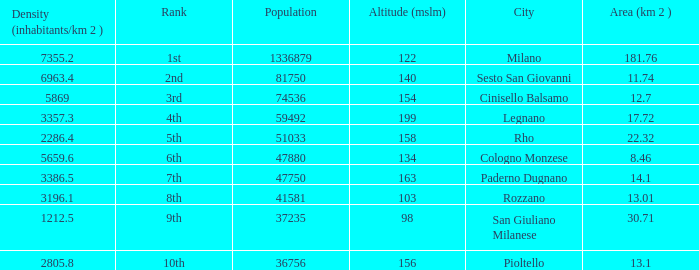Which Population is the highest one that has a Density (inhabitants/km 2) larger than 2805.8, and a Rank of 1st, and an Altitude (mslm) smaller than 122? None. 